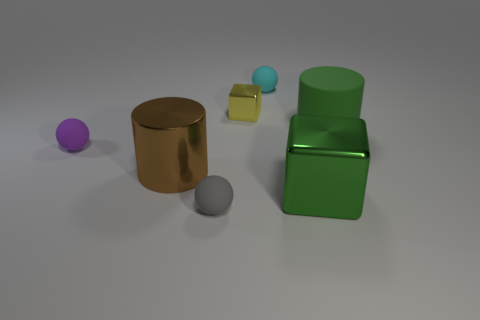There is a tiny purple object; is its shape the same as the thing that is in front of the large green metal block? Indeed, the tiny purple object has a spherical shape which is similar to the small blue object situated in front of the large green metal block. Both objects share a common geometrical form, being round in shape. 